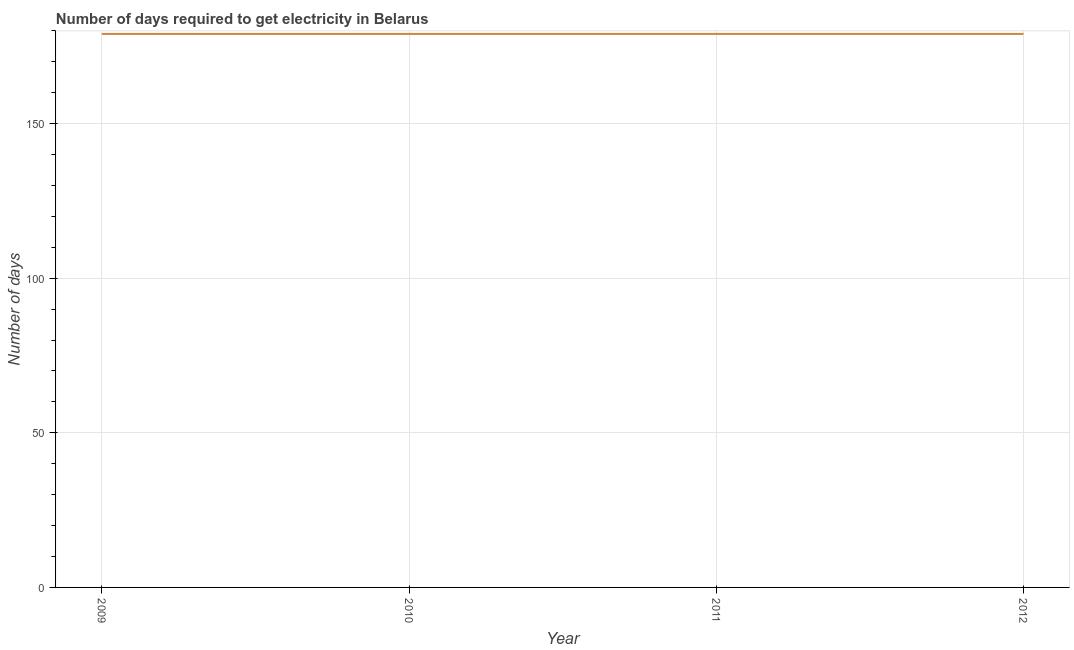What is the time to get electricity in 2009?
Keep it short and to the point. 179. Across all years, what is the maximum time to get electricity?
Your response must be concise. 179. Across all years, what is the minimum time to get electricity?
Your answer should be compact. 179. What is the sum of the time to get electricity?
Your answer should be very brief. 716. What is the average time to get electricity per year?
Make the answer very short. 179. What is the median time to get electricity?
Keep it short and to the point. 179. In how many years, is the time to get electricity greater than 80 ?
Keep it short and to the point. 4. Do a majority of the years between 2010 and 2011 (inclusive) have time to get electricity greater than 70 ?
Your answer should be compact. Yes. What is the ratio of the time to get electricity in 2009 to that in 2012?
Offer a terse response. 1. Is the time to get electricity in 2010 less than that in 2012?
Give a very brief answer. No. Is the sum of the time to get electricity in 2009 and 2010 greater than the maximum time to get electricity across all years?
Offer a terse response. Yes. Does the time to get electricity monotonically increase over the years?
Keep it short and to the point. No. How many lines are there?
Make the answer very short. 1. How many years are there in the graph?
Your answer should be compact. 4. What is the difference between two consecutive major ticks on the Y-axis?
Ensure brevity in your answer.  50. Does the graph contain grids?
Keep it short and to the point. Yes. What is the title of the graph?
Make the answer very short. Number of days required to get electricity in Belarus. What is the label or title of the X-axis?
Ensure brevity in your answer.  Year. What is the label or title of the Y-axis?
Offer a terse response. Number of days. What is the Number of days in 2009?
Provide a succinct answer. 179. What is the Number of days of 2010?
Your answer should be compact. 179. What is the Number of days of 2011?
Your answer should be very brief. 179. What is the Number of days in 2012?
Offer a very short reply. 179. What is the difference between the Number of days in 2009 and 2010?
Your response must be concise. 0. What is the difference between the Number of days in 2010 and 2011?
Make the answer very short. 0. What is the difference between the Number of days in 2010 and 2012?
Make the answer very short. 0. What is the difference between the Number of days in 2011 and 2012?
Provide a succinct answer. 0. What is the ratio of the Number of days in 2009 to that in 2010?
Keep it short and to the point. 1. What is the ratio of the Number of days in 2009 to that in 2011?
Provide a succinct answer. 1. What is the ratio of the Number of days in 2009 to that in 2012?
Your response must be concise. 1. What is the ratio of the Number of days in 2010 to that in 2011?
Provide a short and direct response. 1. What is the ratio of the Number of days in 2011 to that in 2012?
Your answer should be compact. 1. 